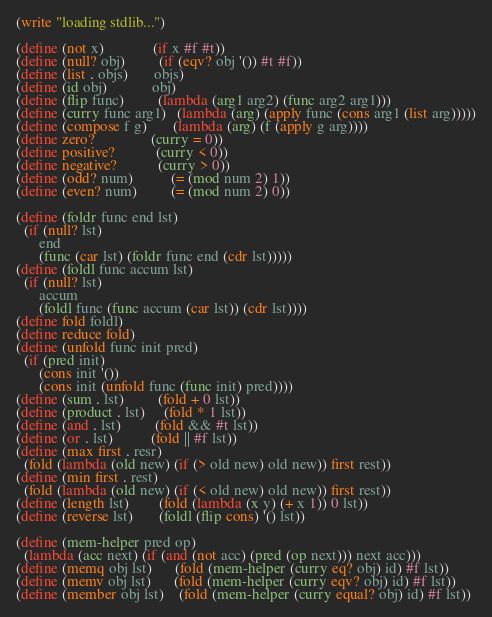Convert code to text. <code><loc_0><loc_0><loc_500><loc_500><_Scheme_>(write "loading stdlib...")

(define (not x)             (if x #f #t))
(define (null? obj)         (if (eqv? obj '()) #t #f))
(define (list . objs)       objs)
(define (id obj)            obj)
(define (flip func)         (lambda (arg1 arg2) (func arg2 arg1)))
(define (curry func arg1)   (lambda (arg) (apply func (cons arg1 (list arg)))))
(define (compose f g)       (lambda (arg) (f (apply g arg))))
(define zero?               (curry = 0))
(define positive?           (curry < 0))
(define negative?           (curry > 0))
(define (odd? num)          (= (mod num 2) 1))
(define (even? num)         (= (mod num 2) 0))

(define (foldr func end lst)
  (if (null? lst)
      end
      (func (car lst) (foldr func end (cdr lst)))))
(define (foldl func accum lst)
  (if (null? lst)
      accum
      (foldl func (func accum (car lst)) (cdr lst))))
(define fold foldl)
(define reduce fold)
(define (unfold func init pred)
  (if (pred init)
      (cons init '())
      (cons init (unfold func (func init) pred))))
(define (sum . lst)         (fold + 0 lst))
(define (product . lst)     (fold * 1 lst))
(define (and . lst)         (fold && #t lst))
(define (or . lst)          (fold || #f lst))
(define (max first . resr)
  (fold (lambda (old new) (if (> old new) old new)) first rest))
(define (min first . rest)
  (fold (lambda (old new) (if (< old new) old new)) first rest))
(define (length lst)        (fold (lambda (x y) (+ x 1)) 0 lst))
(define (reverse lst)       (foldl (flip cons) '() lst))

(define (mem-helper pred op)
  (lambda (acc next) (if (and (not acc) (pred (op next))) next acc)))
(define (memq obj lst)      (fold (mem-helper (curry eq? obj) id) #f lst))
(define (memv obj lst)      (fold (mem-helper (curry eqv? obj) id) #f lst))
(define (member obj lst)    (fold (mem-helper (curry equal? obj) id) #f lst))</code> 